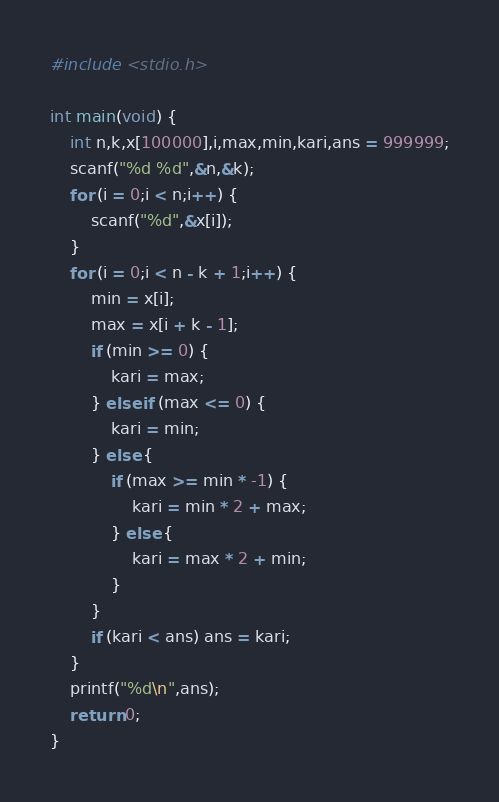Convert code to text. <code><loc_0><loc_0><loc_500><loc_500><_C_>#include <stdio.h>

int main(void) {
    int n,k,x[100000],i,max,min,kari,ans = 999999;
    scanf("%d %d",&n,&k);
    for (i = 0;i < n;i++) {
        scanf("%d",&x[i]);
    }
    for (i = 0;i < n - k + 1;i++) {
        min = x[i];
        max = x[i + k - 1];
        if (min >= 0) {
            kari = max;
        } else if (max <= 0) {
            kari = min;
        } else {
            if (max >= min * -1) {
                kari = min * 2 + max;
            } else {
                kari = max * 2 + min;
            }
        }
        if (kari < ans) ans = kari;
    }
    printf("%d\n",ans);
    return 0;
}
</code> 